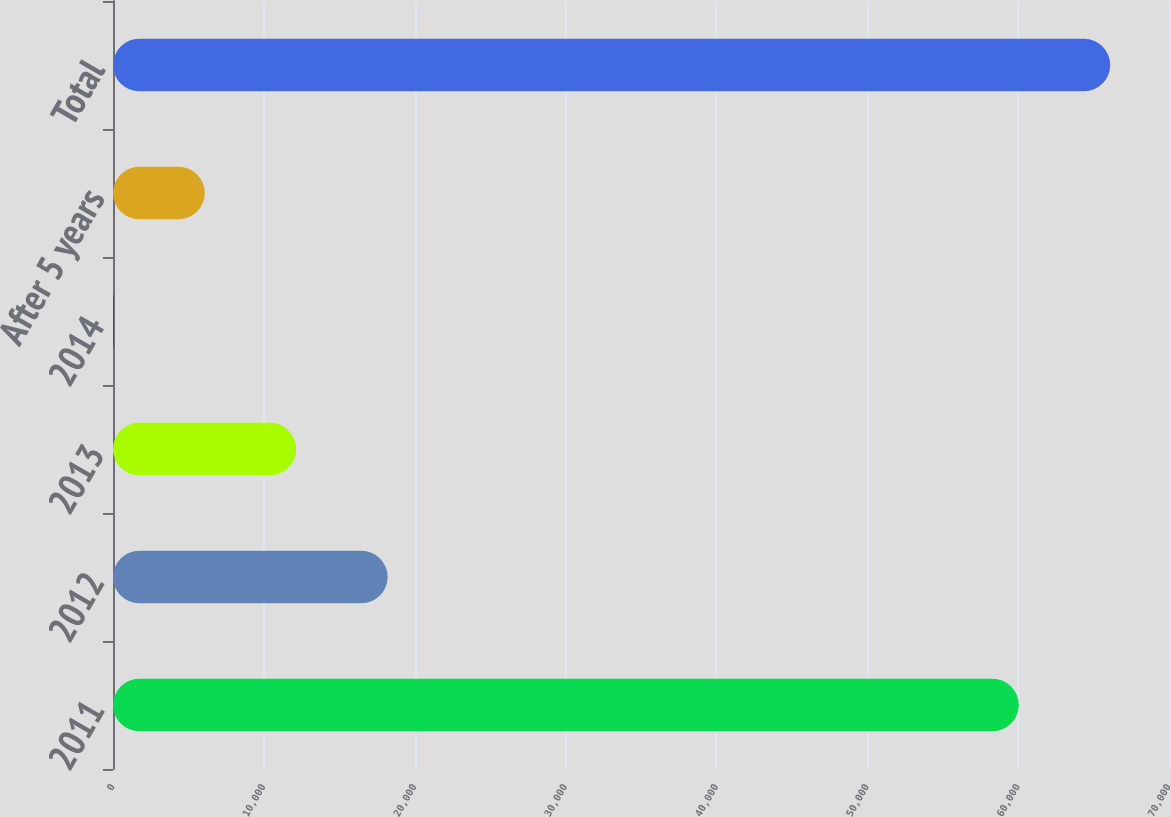Convert chart. <chart><loc_0><loc_0><loc_500><loc_500><bar_chart><fcel>2011<fcel>2012<fcel>2013<fcel>2014<fcel>After 5 years<fcel>Total<nl><fcel>60043<fcel>18206.2<fcel>12144.8<fcel>22<fcel>6083.4<fcel>66104.4<nl></chart> 